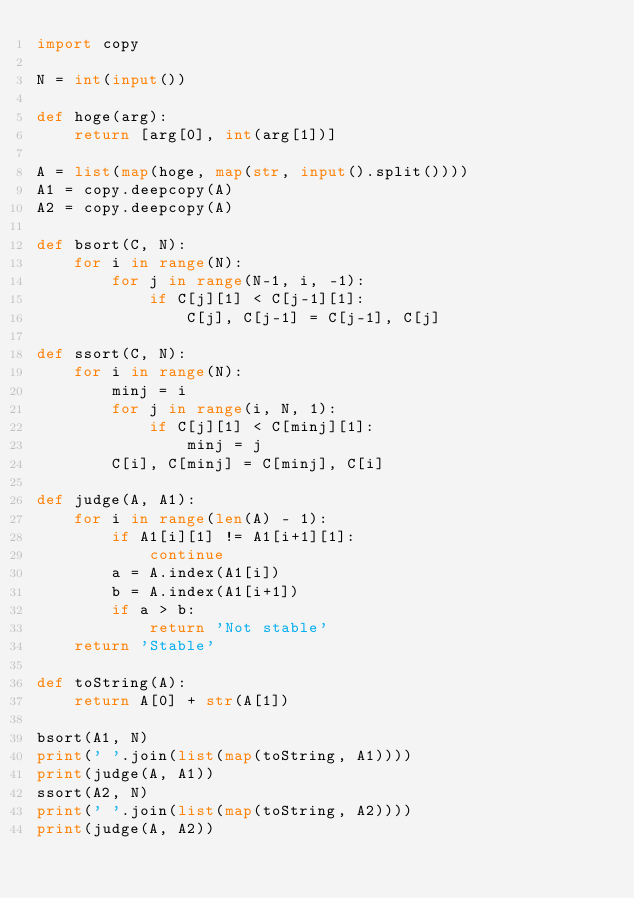Convert code to text. <code><loc_0><loc_0><loc_500><loc_500><_Python_>import copy

N = int(input())

def hoge(arg):
    return [arg[0], int(arg[1])]

A = list(map(hoge, map(str, input().split())))
A1 = copy.deepcopy(A)
A2 = copy.deepcopy(A)

def bsort(C, N):
    for i in range(N):
        for j in range(N-1, i, -1):
            if C[j][1] < C[j-1][1]:
                C[j], C[j-1] = C[j-1], C[j]

def ssort(C, N):
    for i in range(N):
        minj = i
        for j in range(i, N, 1):
            if C[j][1] < C[minj][1]:
                minj = j
        C[i], C[minj] = C[minj], C[i]

def judge(A, A1):
    for i in range(len(A) - 1):
        if A1[i][1] != A1[i+1][1]:
            continue
        a = A.index(A1[i])
        b = A.index(A1[i+1])
        if a > b:
            return 'Not stable'
    return 'Stable'

def toString(A):
    return A[0] + str(A[1])

bsort(A1, N)
print(' '.join(list(map(toString, A1))))
print(judge(A, A1))
ssort(A2, N)
print(' '.join(list(map(toString, A2))))
print(judge(A, A2))

</code> 